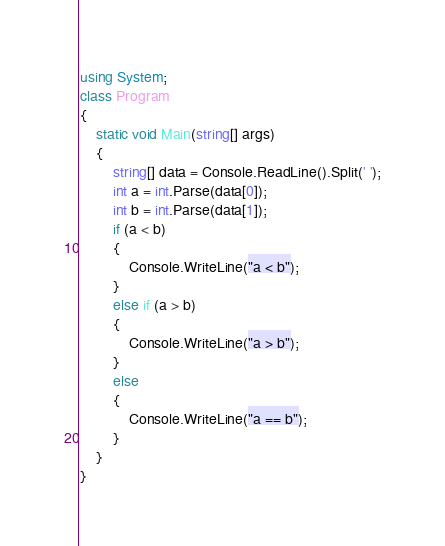Convert code to text. <code><loc_0><loc_0><loc_500><loc_500><_C#_>using System;
class Program
{
    static void Main(string[] args)
    {
        string[] data = Console.ReadLine().Split(' ');
        int a = int.Parse(data[0]);
        int b = int.Parse(data[1]);
        if (a < b)
        {
            Console.WriteLine("a < b");
        }
        else if (a > b)
        {
            Console.WriteLine("a > b");
        }
        else
        {
            Console.WriteLine("a == b");
        }
    }
}</code> 